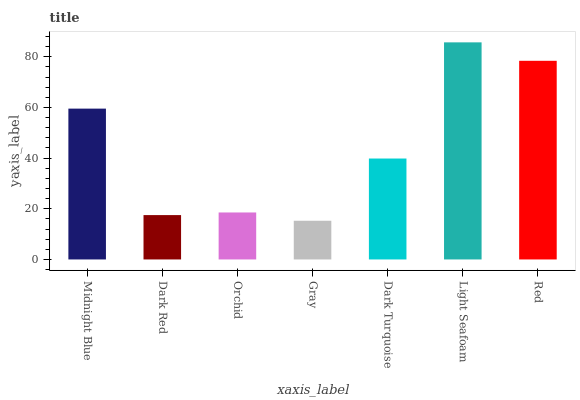Is Gray the minimum?
Answer yes or no. Yes. Is Light Seafoam the maximum?
Answer yes or no. Yes. Is Dark Red the minimum?
Answer yes or no. No. Is Dark Red the maximum?
Answer yes or no. No. Is Midnight Blue greater than Dark Red?
Answer yes or no. Yes. Is Dark Red less than Midnight Blue?
Answer yes or no. Yes. Is Dark Red greater than Midnight Blue?
Answer yes or no. No. Is Midnight Blue less than Dark Red?
Answer yes or no. No. Is Dark Turquoise the high median?
Answer yes or no. Yes. Is Dark Turquoise the low median?
Answer yes or no. Yes. Is Gray the high median?
Answer yes or no. No. Is Gray the low median?
Answer yes or no. No. 